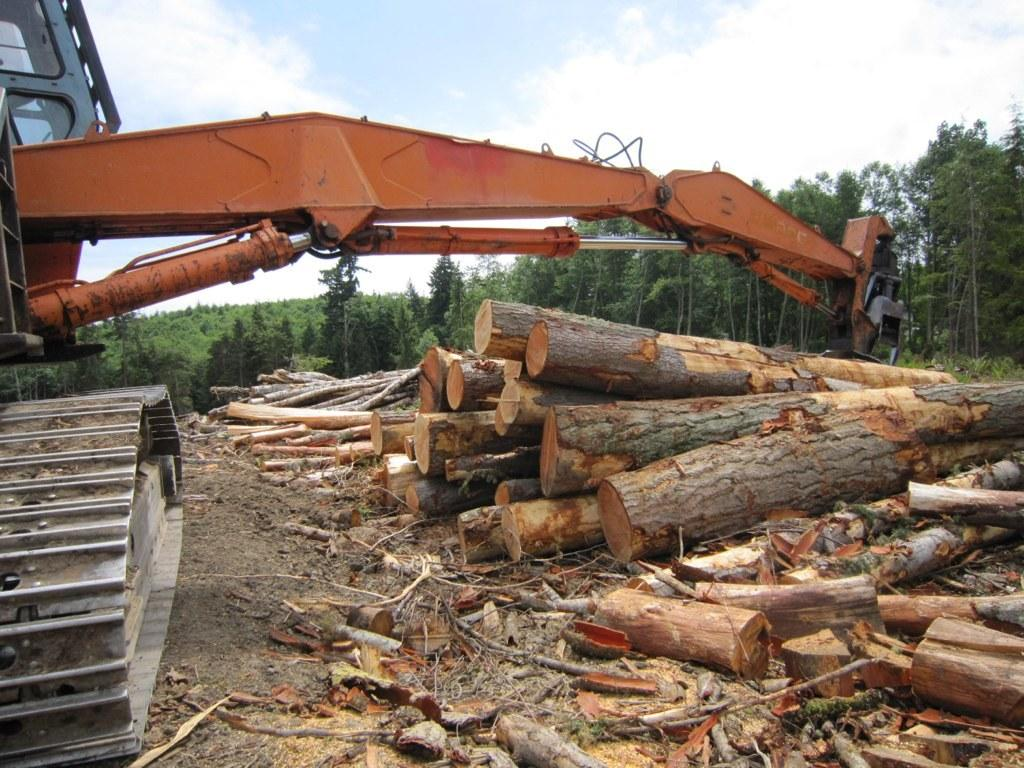What type of machinery is located on the left side of the image? There is a JCB on the left side of the image. What can be seen on the right side of the image? There are logs on the right side of the image. What type of natural environment is visible in the background of the image? There are trees in the background of the image. Can you see an umbrella being used in space in the image? There is no umbrella or space depicted in the image; it features a JCB and logs with trees in the background. How many people are gathered in a group in the image? There is no group of people present in the image. 